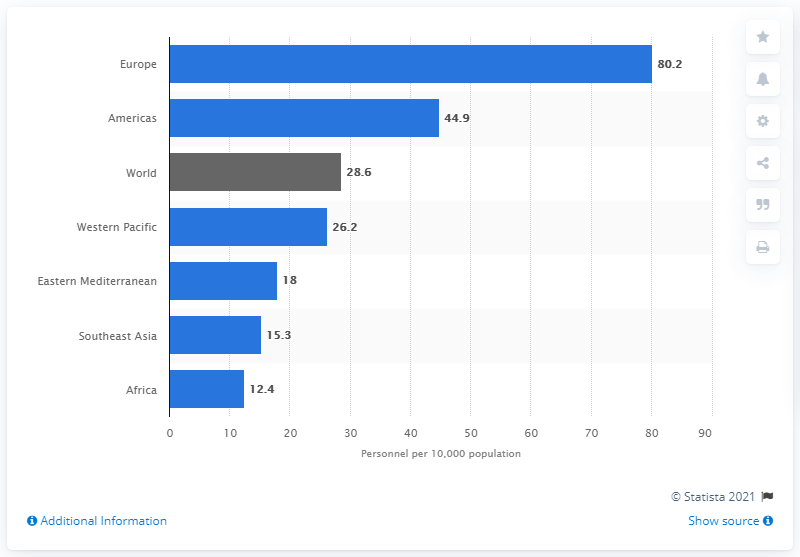Indicate a few pertinent items in this graphic. In 2013, the average number of nursing and midwifery personnel in Southeast Asia was 15.3. 